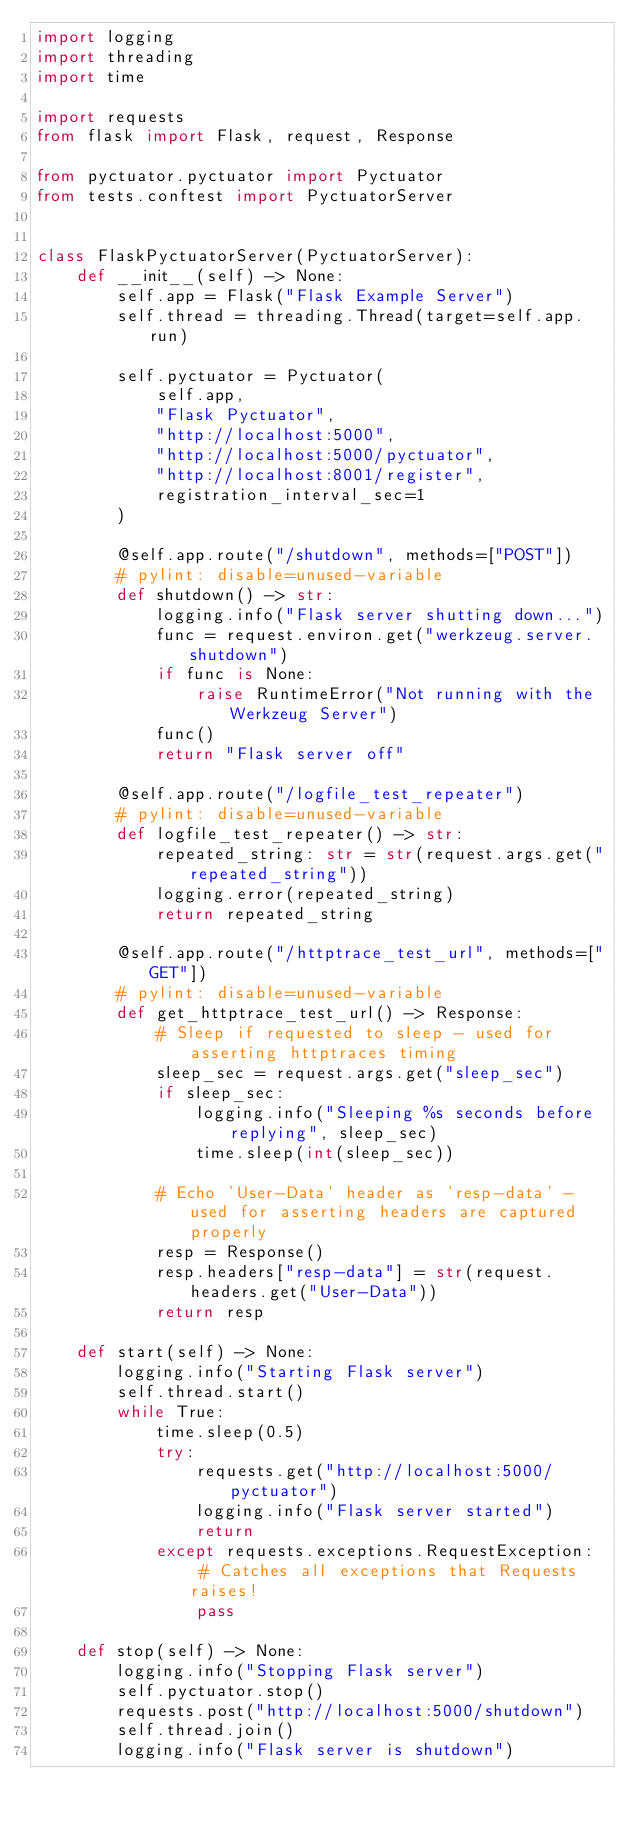<code> <loc_0><loc_0><loc_500><loc_500><_Python_>import logging
import threading
import time

import requests
from flask import Flask, request, Response

from pyctuator.pyctuator import Pyctuator
from tests.conftest import PyctuatorServer


class FlaskPyctuatorServer(PyctuatorServer):
    def __init__(self) -> None:
        self.app = Flask("Flask Example Server")
        self.thread = threading.Thread(target=self.app.run)

        self.pyctuator = Pyctuator(
            self.app,
            "Flask Pyctuator",
            "http://localhost:5000",
            "http://localhost:5000/pyctuator",
            "http://localhost:8001/register",
            registration_interval_sec=1
        )

        @self.app.route("/shutdown", methods=["POST"])
        # pylint: disable=unused-variable
        def shutdown() -> str:
            logging.info("Flask server shutting down...")
            func = request.environ.get("werkzeug.server.shutdown")
            if func is None:
                raise RuntimeError("Not running with the Werkzeug Server")
            func()
            return "Flask server off"

        @self.app.route("/logfile_test_repeater")
        # pylint: disable=unused-variable
        def logfile_test_repeater() -> str:
            repeated_string: str = str(request.args.get("repeated_string"))
            logging.error(repeated_string)
            return repeated_string

        @self.app.route("/httptrace_test_url", methods=["GET"])
        # pylint: disable=unused-variable
        def get_httptrace_test_url() -> Response:
            # Sleep if requested to sleep - used for asserting httptraces timing
            sleep_sec = request.args.get("sleep_sec")
            if sleep_sec:
                logging.info("Sleeping %s seconds before replying", sleep_sec)
                time.sleep(int(sleep_sec))

            # Echo 'User-Data' header as 'resp-data' - used for asserting headers are captured properly
            resp = Response()
            resp.headers["resp-data"] = str(request.headers.get("User-Data"))
            return resp

    def start(self) -> None:
        logging.info("Starting Flask server")
        self.thread.start()
        while True:
            time.sleep(0.5)
            try:
                requests.get("http://localhost:5000/pyctuator")
                logging.info("Flask server started")
                return
            except requests.exceptions.RequestException:  # Catches all exceptions that Requests raises!
                pass

    def stop(self) -> None:
        logging.info("Stopping Flask server")
        self.pyctuator.stop()
        requests.post("http://localhost:5000/shutdown")
        self.thread.join()
        logging.info("Flask server is shutdown")
</code> 